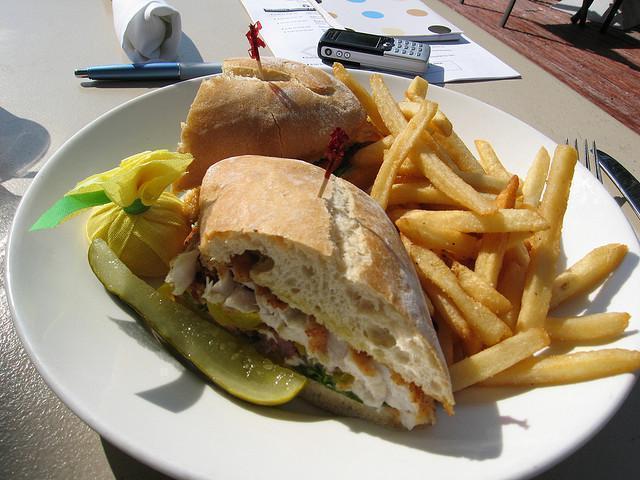Which food element here is likely most sour?
Choose the correct response, then elucidate: 'Answer: answer
Rationale: rationale.'
Options: Fries, meat, bread, pickle. Answer: pickle.
Rationale: Pickles are made with vinegar. 